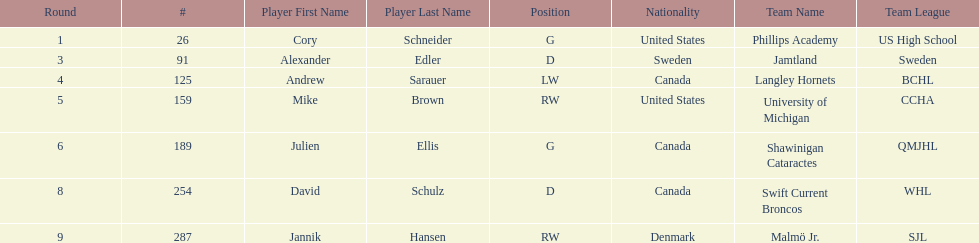List only the american players. Cory Schneider (G), Mike Brown (RW). 